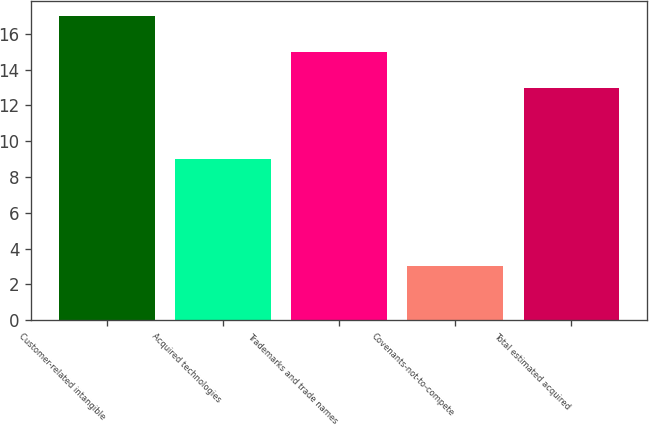<chart> <loc_0><loc_0><loc_500><loc_500><bar_chart><fcel>Customer-related intangible<fcel>Acquired technologies<fcel>Trademarks and trade names<fcel>Covenants-not-to-compete<fcel>Total estimated acquired<nl><fcel>17<fcel>9<fcel>15<fcel>3<fcel>13<nl></chart> 